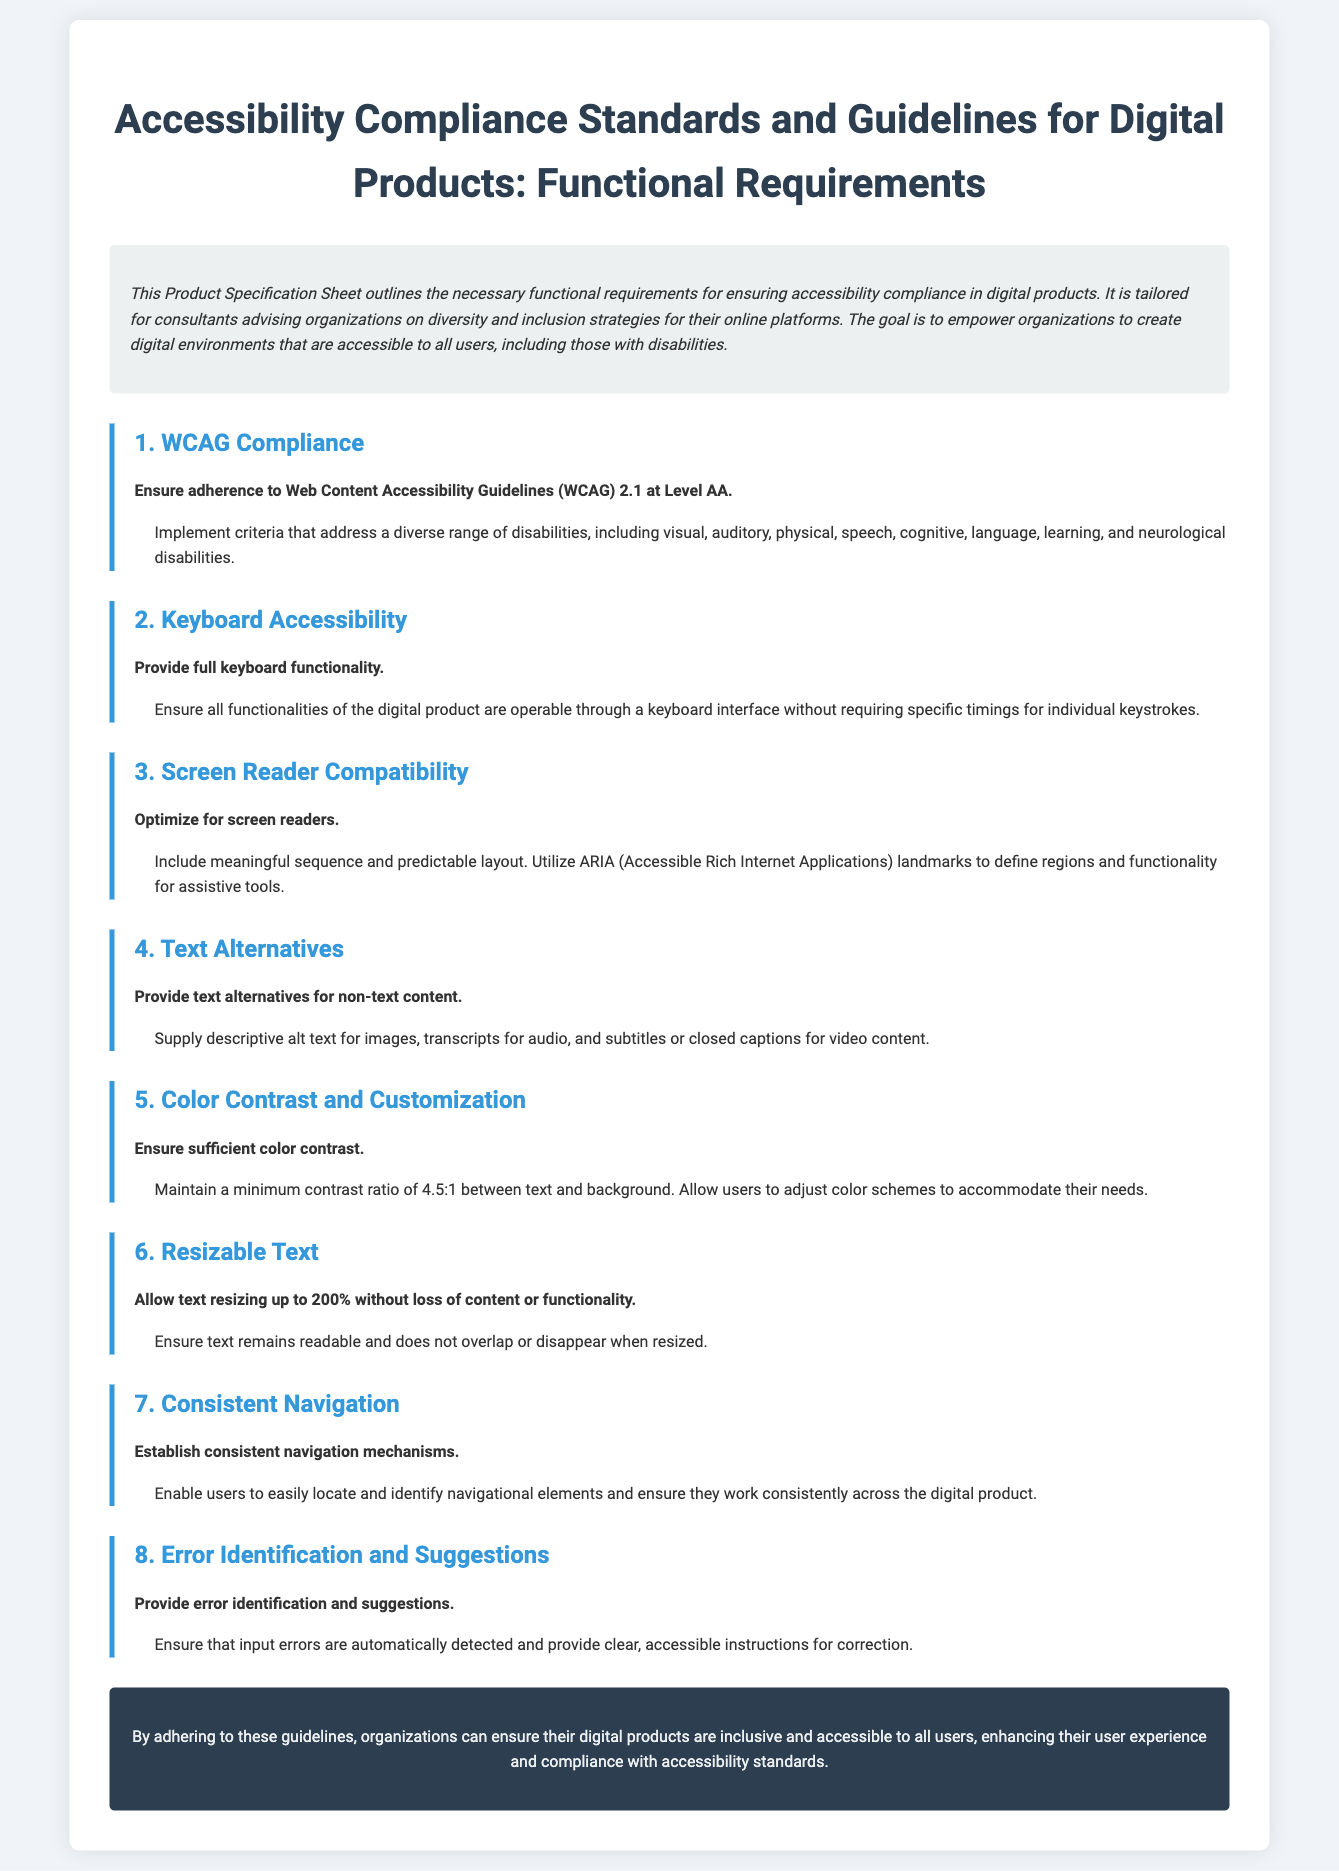What is the title of the document? The title is shown prominently at the top of the document and indicates the content covered.
Answer: Accessibility Compliance Standards and Guidelines for Digital Products: Functional Requirements What is the minimum color contrast ratio mentioned? The document specifies a necessary minimum contrast ratio for text and background, which is critical for accessibility.
Answer: 4.5:1 What is one of the requirements for keyboard accessibility? The requirements for keyboard functionality are listed in the section related to keyboard accessibility.
Answer: Provide full keyboard functionality What level of WCAG compliance is required? The document outlines the specific level of adherence necessary for accessibility guidelines.
Answer: Level AA What is the maximum text resizing allowed? There is a specific limit mentioned regarding how much text can be resized without compromising readability.
Answer: 200% What should be provided as text alternatives? The document explains what types of text alternatives should be available for non-text content.
Answer: descriptive alt text for images What is required for error identification? This aspect discusses how errors in user input should be handled according to the document.
Answer: Provide clear, accessible instructions for correction Which assistive tool should be optimized for? The document emphasizes the importance of compatibility with a specific type of assistive technology.
Answer: screen readers What is emphasized in the consistent navigation section? The requirements outlined in this section relate to a general aspect of user experience and usability.
Answer: Establish consistent navigation mechanisms 